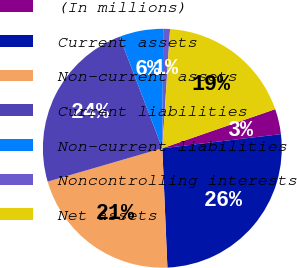<chart> <loc_0><loc_0><loc_500><loc_500><pie_chart><fcel>(In millions)<fcel>Current assets<fcel>Non-current assets<fcel>Current liabilities<fcel>Non-current liabilities<fcel>Noncontrolling interests<fcel>Net assets<nl><fcel>3.42%<fcel>26.21%<fcel>21.17%<fcel>23.69%<fcel>5.94%<fcel>0.91%<fcel>18.66%<nl></chart> 